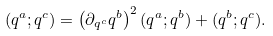Convert formula to latex. <formula><loc_0><loc_0><loc_500><loc_500>( q ^ { a } ; q ^ { c } ) = \left ( \partial _ { q ^ { c } } q ^ { b } \right ) ^ { 2 } ( q ^ { a } ; q ^ { b } ) + ( q ^ { b } ; q ^ { c } ) .</formula> 